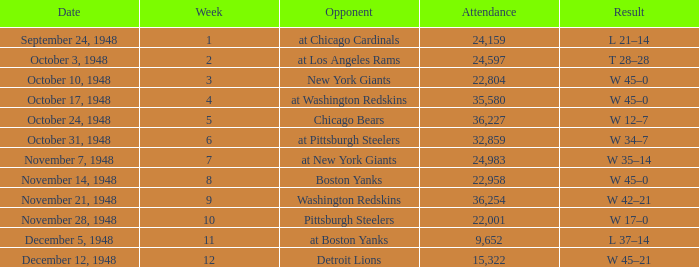What is the lowest value for Week, when the Attendance is greater than 22,958, and when the Opponent is At Chicago Cardinals? 1.0. 